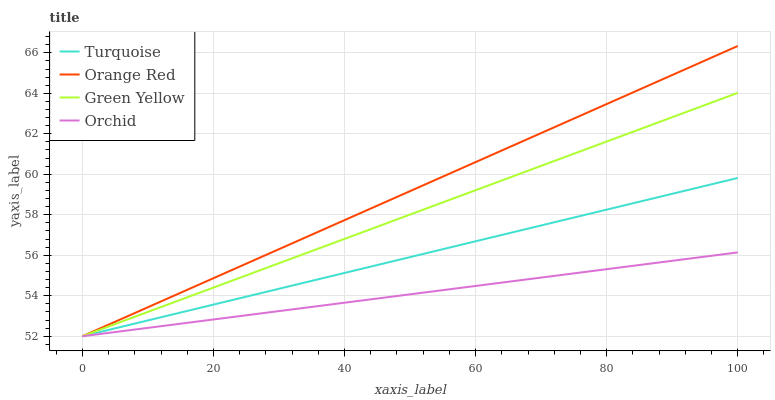Does Orchid have the minimum area under the curve?
Answer yes or no. Yes. Does Orange Red have the maximum area under the curve?
Answer yes or no. Yes. Does Green Yellow have the minimum area under the curve?
Answer yes or no. No. Does Green Yellow have the maximum area under the curve?
Answer yes or no. No. Is Turquoise the smoothest?
Answer yes or no. Yes. Is Orchid the roughest?
Answer yes or no. Yes. Is Green Yellow the smoothest?
Answer yes or no. No. Is Green Yellow the roughest?
Answer yes or no. No. Does Orange Red have the highest value?
Answer yes or no. Yes. Does Green Yellow have the highest value?
Answer yes or no. No. Does Orchid intersect Orange Red?
Answer yes or no. Yes. Is Orchid less than Orange Red?
Answer yes or no. No. Is Orchid greater than Orange Red?
Answer yes or no. No. 